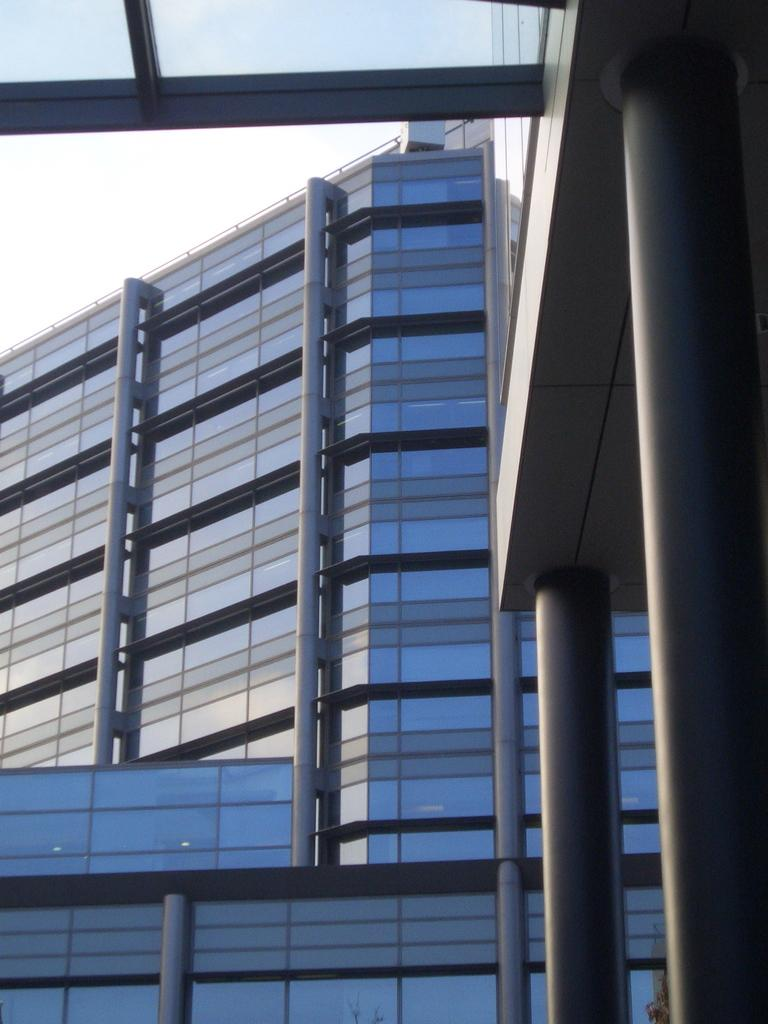What type of buildings can be seen in the image? There are buildings with glass in the image. What is the condition of the sky in the image? The sky is cloudy in the image. How many servants are visible in the image? There are no servants present in the image. What type of coil can be seen in the image? There is no coil present in the image. 